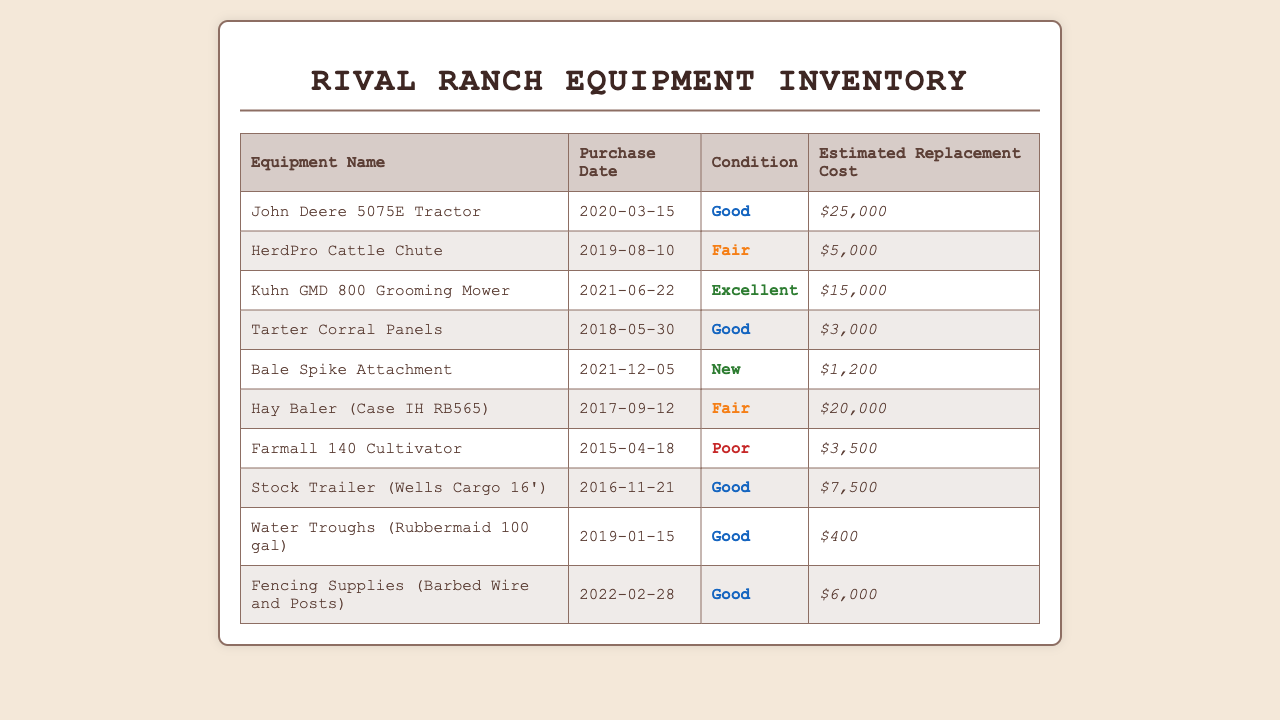What is the purchase date of the John Deere 5075E Tractor? The purchase date is listed in the document under the "Purchase Date" column for the John Deere 5075E Tractor.
Answer: 2020-03-15 What is the estimated replacement cost of the Bale Spike Attachment? The estimated replacement cost is displayed in the document alongside the Bale Spike Attachment entry.
Answer: $1,200 Which equipment has the condition listed as "Fair"? The equipment with the condition listed as "Fair" can be found in the "Condition" column; there are two entries.
Answer: HerdPro Cattle Chute, Hay Baler (Case IH RB565) What is the condition of the Kuhn GMD 800 Grooming Mower? The condition of the Kuhn GMD 800 Grooming Mower is specified in the document, in the "Condition" column.
Answer: Excellent What is the oldest equipment listed in the inventory? The purchase dates of all equipment are compared to determine which one is the oldest; it is found by examining the "Purchase Date" column.
Answer: Farmall 140 Cultivator What total estimated replacement cost does the inventory have? The total estimated replacement cost is the sum of all estimated costs provided in the document.
Answer: $81,100 How many equipment items are classified as "Good"? The number of items with the condition "Good" can be counted from the "Condition" column in the table.
Answer: 5 What equipment was purchased in 2022? The purchase year is identifiable by examining the "Purchase Date" entries for the year 2022; it indicates which item was purchased.
Answer: Fencing Supplies (Barbed Wire and Posts) What are the two types of conditions listed in the inventory? The conditions are categorized and can be seen in the "Condition" column; identifying unique conditions gives their types.
Answer: Excellent, Fair, Good, Poor, New 